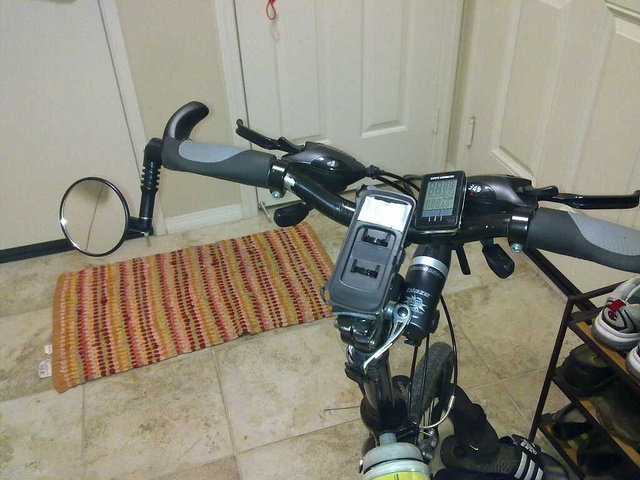Describe the objects in this image and their specific colors. I can see bicycle in darkgray, black, gray, and purple tones and cell phone in darkgray, black, and gray tones in this image. 